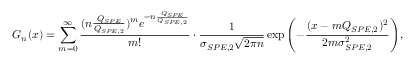Convert formula to latex. <formula><loc_0><loc_0><loc_500><loc_500>G _ { n } ( x ) = \sum _ { m = 0 } ^ { \infty } \frac { ( n \frac { Q _ { S P E } } { Q _ { S P E , 2 } } ) ^ { m } e ^ { - n \frac { Q _ { S P E } } { Q _ { S P E , 2 } } } } { m ! } \cdot \frac { 1 } { \sigma _ { S P E , 2 } \sqrt { 2 \pi n } } \exp { \left ( - \frac { ( x - m Q _ { S P E , 2 } ) ^ { 2 } } { 2 m \sigma _ { S P E , 2 } ^ { 2 } } \right ) } ,</formula> 